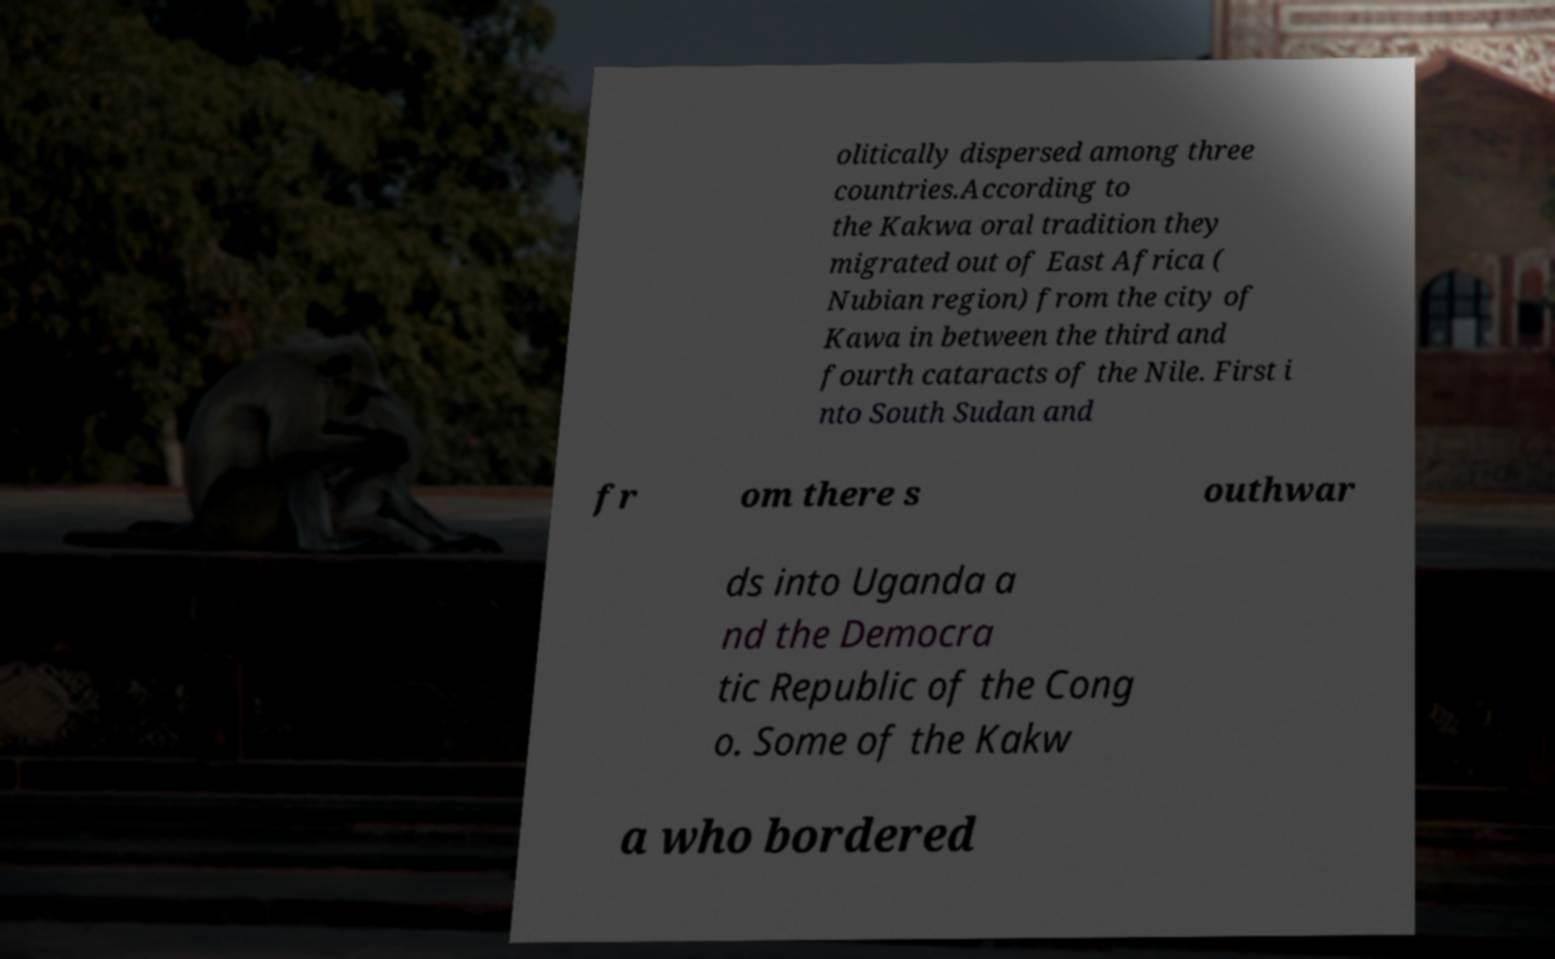Please read and relay the text visible in this image. What does it say? olitically dispersed among three countries.According to the Kakwa oral tradition they migrated out of East Africa ( Nubian region) from the city of Kawa in between the third and fourth cataracts of the Nile. First i nto South Sudan and fr om there s outhwar ds into Uganda a nd the Democra tic Republic of the Cong o. Some of the Kakw a who bordered 